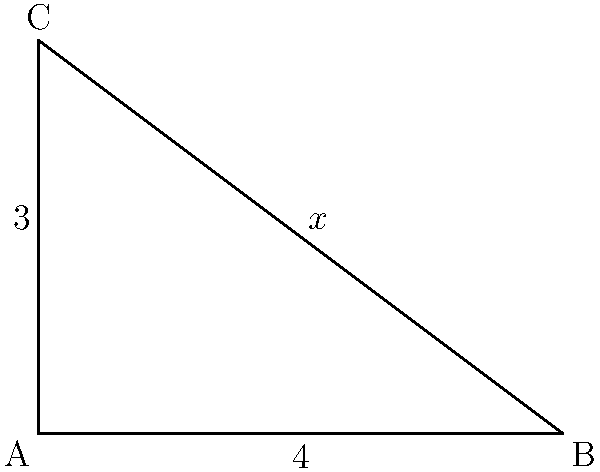In your latest marketing campaign for a tech product, you're using a triangular display stand. The base of the stand is 4 feet long, and the height is 3 feet. What is the length of the hypotenuse (to the nearest tenth of a foot), and what are the measures of the two acute angles in the triangle? Let's approach this step-by-step:

1) First, we need to find the length of the hypotenuse. We can use the Pythagorean theorem for this:

   $a^2 + b^2 = c^2$

   Where $a$ and $b$ are the known sides, and $c$ is the hypotenuse.

2) Plugging in our values:

   $4^2 + 3^2 = c^2$
   $16 + 9 = c^2$
   $25 = c^2$

3) Taking the square root of both sides:

   $c = \sqrt{25} = 5$

4) Now for the angles. We can use the trigonometric ratios. Let's find the angle at A first:

   $\tan A = \frac{\text{opposite}}{\text{adjacent}} = \frac{3}{4}$

5) To find angle A, we use the inverse tangent:

   $A = \tan^{-1}(\frac{3}{4}) \approx 36.9°$

6) For angle B, we can either use the same method or simply subtract angle A from 90°:

   $B = 90° - 36.9° = 53.1°$

7) We can verify this using the sine ratio:

   $\sin B = \frac{\text{opposite}}{\text{hypotenuse}} = \frac{3}{5} = 0.6$
   
   $B = \sin^{-1}(0.6) \approx 53.1°$

Thus, our results match.
Answer: Hypotenuse: 5 feet; Angles: 36.9° and 53.1° 